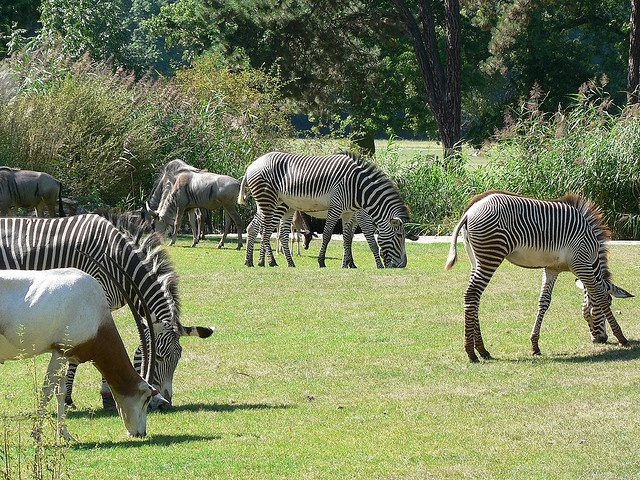Describe the objects in this image and their specific colors. I can see zebra in black, gray, darkgray, and white tones, zebra in black, gray, darkgray, and olive tones, zebra in black, gray, darkgray, and white tones, and zebra in black, gray, and darkgray tones in this image. 